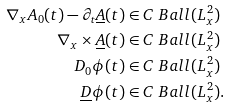Convert formula to latex. <formula><loc_0><loc_0><loc_500><loc_500>\nabla _ { x } A _ { 0 } ( t ) - \partial _ { t } \underline { A } ( t ) & \in C \ B a l l ( L ^ { 2 } _ { x } ) \\ \nabla _ { x } \times \underline { A } ( t ) & \in C \ B a l l ( L ^ { 2 } _ { x } ) \\ D _ { 0 } \phi ( t ) & \in C \ B a l l ( L ^ { 2 } _ { x } ) \\ \underline { D } \phi ( t ) & \in C \ B a l l ( L ^ { 2 } _ { x } ) .</formula> 